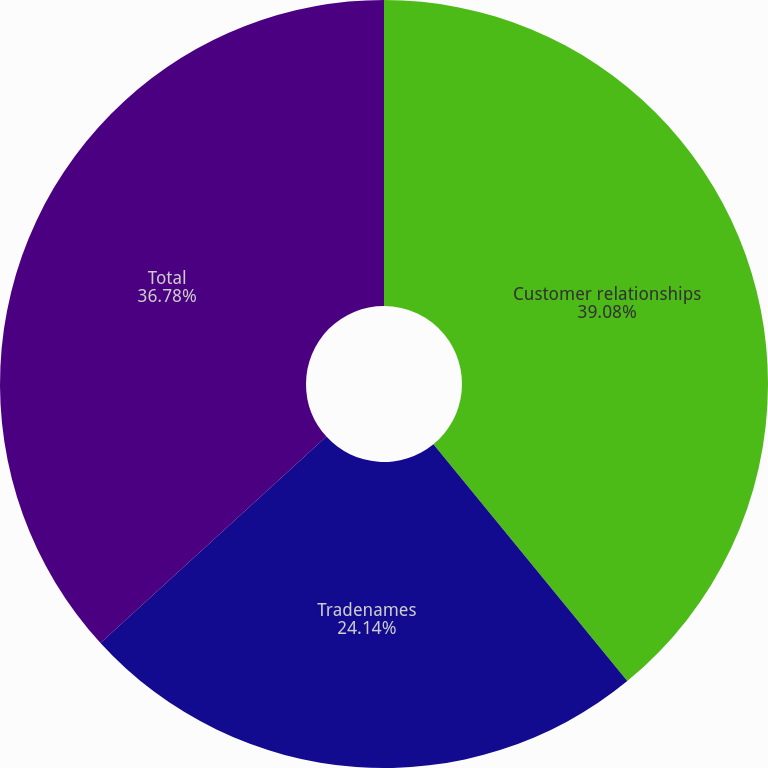<chart> <loc_0><loc_0><loc_500><loc_500><pie_chart><fcel>Customer relationships<fcel>Tradenames<fcel>Total<nl><fcel>39.08%<fcel>24.14%<fcel>36.78%<nl></chart> 